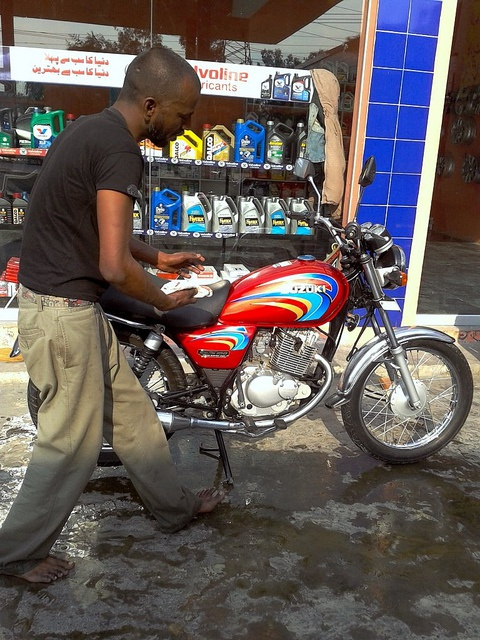Describe the objects in this image and their specific colors. I can see people in maroon, black, gray, and tan tones, motorcycle in maroon, black, gray, ivory, and darkgray tones, bottle in maroon, blue, navy, and black tones, bottle in maroon, tan, white, olive, and gray tones, and bottle in maroon, ivory, gray, darkgray, and black tones in this image. 